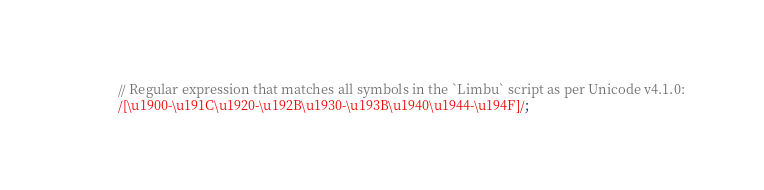<code> <loc_0><loc_0><loc_500><loc_500><_JavaScript_>// Regular expression that matches all symbols in the `Limbu` script as per Unicode v4.1.0:
/[\u1900-\u191C\u1920-\u192B\u1930-\u193B\u1940\u1944-\u194F]/;</code> 